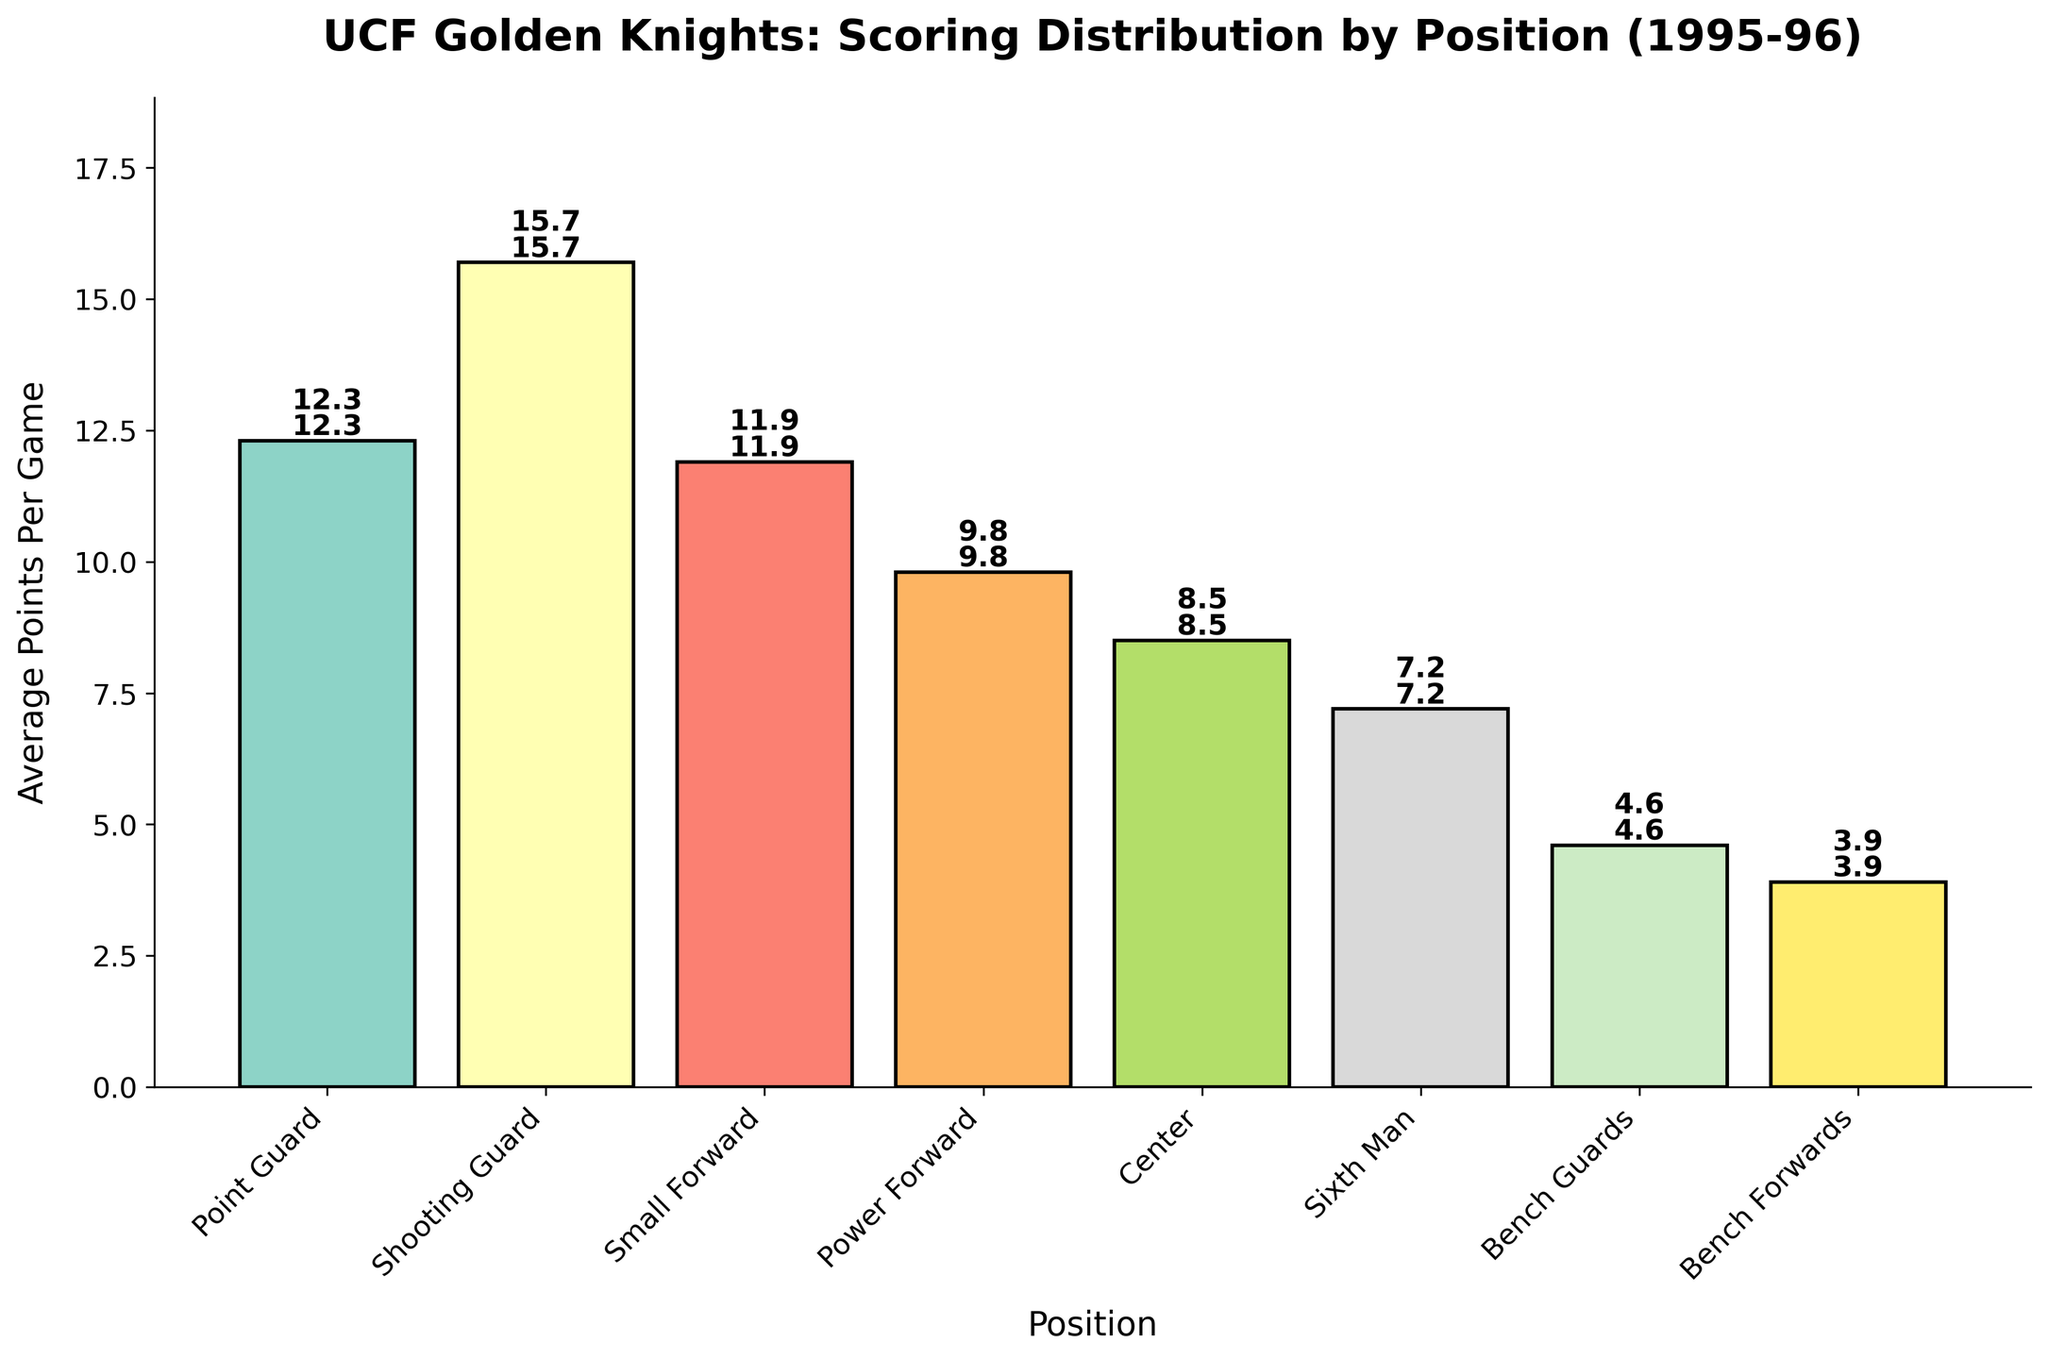What's the total average points per game for all positions combined? Sum up all the average points per game: 12.3 (Point Guard) + 15.7 (Shooting Guard) + 11.9 (Small Forward) + 9.8 (Power Forward) + 8.5 (Center) + 7.2 (Sixth Man) + 4.6 (Bench Guards) + 3.9 (Bench Forwards) = 73.9
Answer: 73.9 Which position has the highest average points per game? By looking at the heights of the bars, note that the Shooting Guard position has the highest bar at 15.7 points per game.
Answer: Shooting Guard How much higher is the average points per game of the Shooting Guard compared to the Power Forward? Subtract the average points per game of the Power Forward from the Shooting Guard: 15.7 - 9.8 = 5.9
Answer: 5.9 Which positions have an average points per game greater than 10? By looking at the bar heights, positions with average points per game greater than 10 are Point Guard (12.3), Shooting Guard (15.7), and Small Forward (11.9).
Answer: Point Guard, Shooting Guard, Small Forward What is the percentage contribution of the Center's average points per game to the total average points per game? Divide the Center's average points per game by the total and multiply by 100: (8.5 / 73.9) * 100 ≈ 11.5%
Answer: 11.5% Which position has the smallest average points per game and what is it? By assessing the bar heights, the Bench Forwards position has the shortest bar with 3.9 points per game.
Answer: Bench Forwards - 3.9 How much more do the starting five (Point Guard, Shooting Guard, Small Forward, Power Forward, Center) average in points per game compared to the non-starters (Sixth Man, Bench Guards, Bench Forwards)? Sum up the averages for the starting five and non-starters, then subtract the totals: (12.3 + 15.7 + 11.9 + 9.8 + 8.5) - (7.2 + 4.6 + 3.9) = 58.2 - 15.7 = 42.5
Answer: 42.5 Among the starting five, which position contributes the least to the average points per game? By observing the bars for the starting five positions (Point Guard, Shooting Guard, Small Forward, Power Forward, Center), the Center has the lowest bar at 8.5 points per game.
Answer: Center What is the average points per game for the Bench players (Sixth Man, Bench Guards, Bench Forwards)? Calculate the average of the bench players' points per game: (7.2 + 4.6 + 3.9) / 3 = 15.7 / 3 ≈ 5.23
Answer: 5.23 How does the average points per game of the Sixth Man compare to the combined average of the Bench Guards and Bench Forwards? Compare the Sixth Man (7.2) to the sum of Bench Guards and Bench Forwards (4.6 + 3.9 = 8.5).
Answer: 7.2 is slightly less than 8.5 